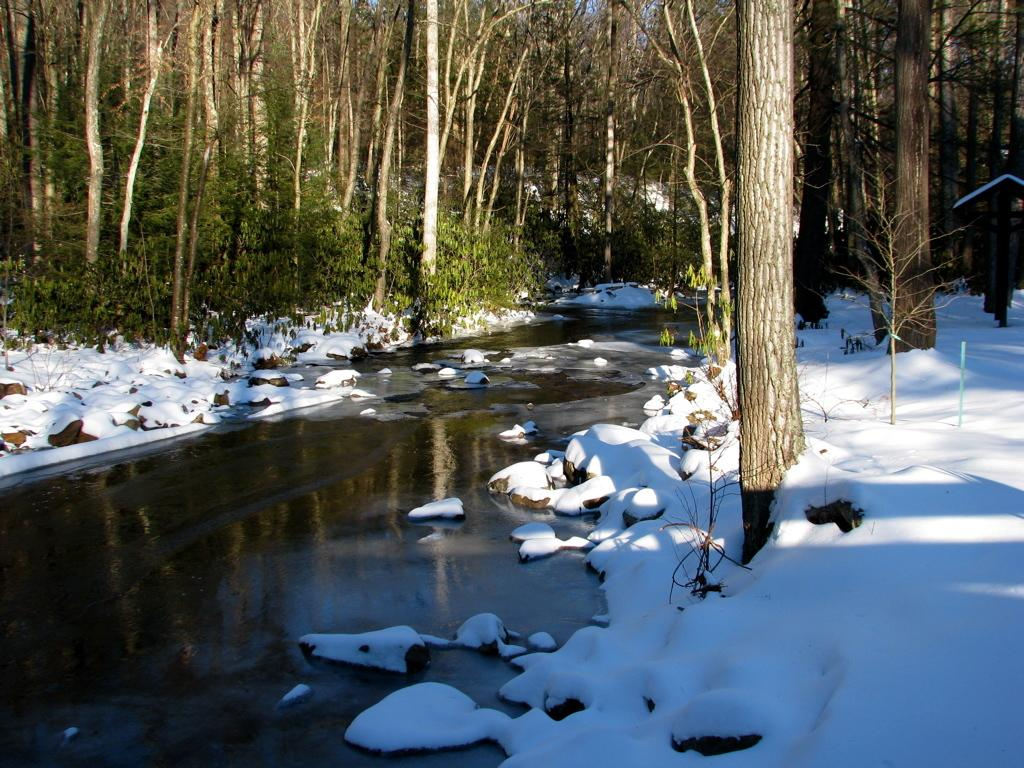What type of natural elements can be seen in the image? There are trees and plants in the image. What structure is present in the image? There is a stand in the image. What is the liquid visible in the image? There is water visible in the image. What type of weather condition is depicted in the image? There is snow in the image, indicating a cold or wintery condition. What type of geological feature can be seen in the image? There are rocks in the image. Can you see the kitten's desire for attention in the image? There is no kitten present in the image, so it is not possible to determine its desires. 